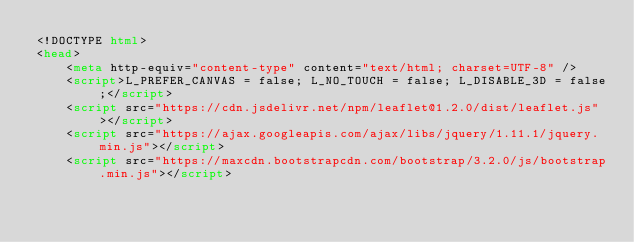Convert code to text. <code><loc_0><loc_0><loc_500><loc_500><_HTML_><!DOCTYPE html>
<head>    
    <meta http-equiv="content-type" content="text/html; charset=UTF-8" />
    <script>L_PREFER_CANVAS = false; L_NO_TOUCH = false; L_DISABLE_3D = false;</script>
    <script src="https://cdn.jsdelivr.net/npm/leaflet@1.2.0/dist/leaflet.js"></script>
    <script src="https://ajax.googleapis.com/ajax/libs/jquery/1.11.1/jquery.min.js"></script>
    <script src="https://maxcdn.bootstrapcdn.com/bootstrap/3.2.0/js/bootstrap.min.js"></script></code> 